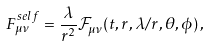Convert formula to latex. <formula><loc_0><loc_0><loc_500><loc_500>F _ { \mu \nu } ^ { s e l f } = \frac { \lambda } { r ^ { 2 } } \mathcal { F } _ { \mu \nu } ( t , r , \lambda / r , \theta , \phi ) \, ,</formula> 